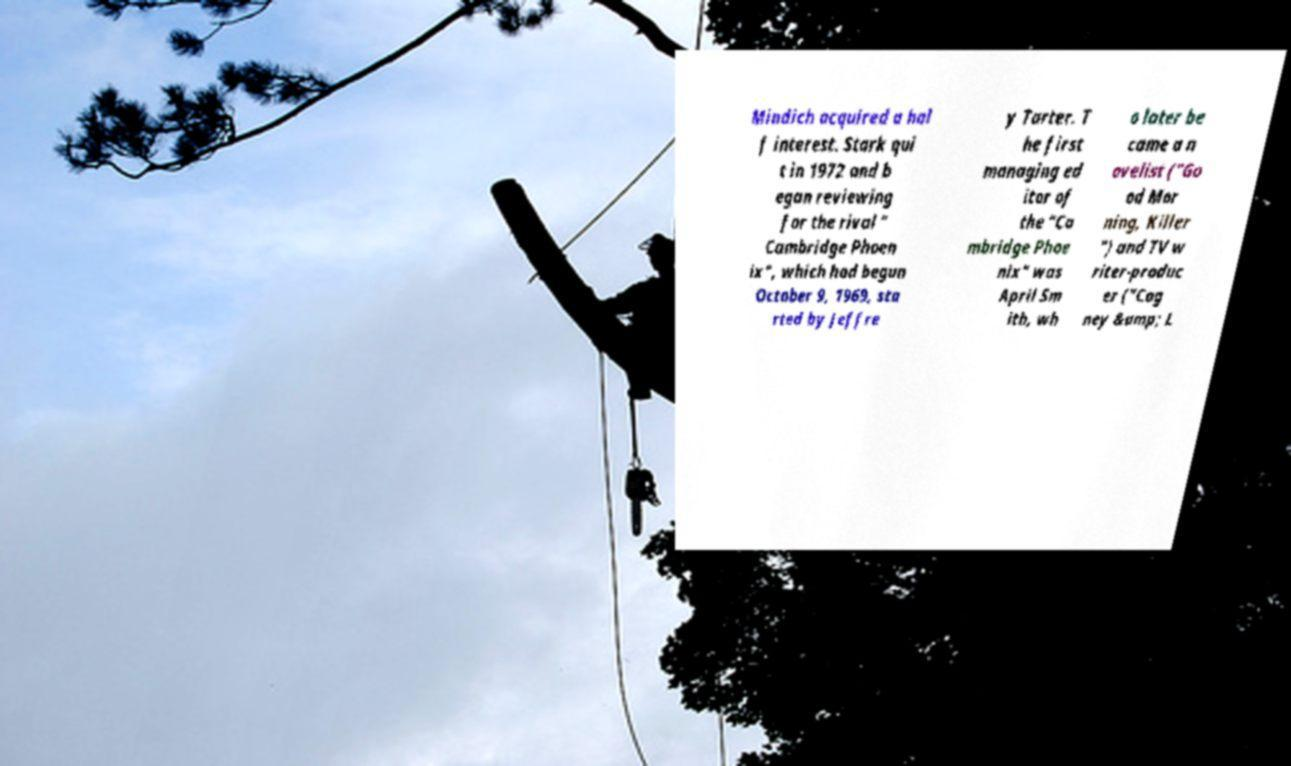Please identify and transcribe the text found in this image. Mindich acquired a hal f interest. Stark qui t in 1972 and b egan reviewing for the rival " Cambridge Phoen ix", which had begun October 9, 1969, sta rted by Jeffre y Tarter. T he first managing ed itor of the "Ca mbridge Phoe nix" was April Sm ith, wh o later be came a n ovelist ("Go od Mor ning, Killer ") and TV w riter-produc er ("Cag ney &amp; L 